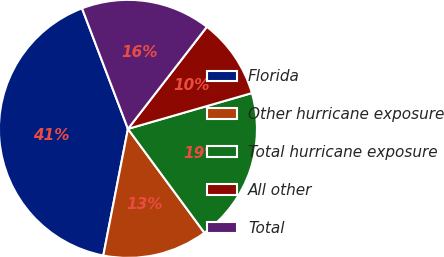<chart> <loc_0><loc_0><loc_500><loc_500><pie_chart><fcel>Florida<fcel>Other hurricane exposure<fcel>Total hurricane exposure<fcel>All other<fcel>Total<nl><fcel>41.15%<fcel>13.16%<fcel>19.38%<fcel>10.05%<fcel>16.27%<nl></chart> 